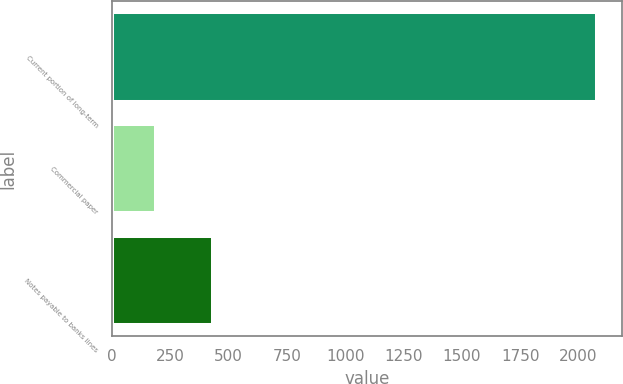Convert chart to OTSL. <chart><loc_0><loc_0><loc_500><loc_500><bar_chart><fcel>Current portion of long-term<fcel>Commercial paper<fcel>Notes payable to banks lines<nl><fcel>2081<fcel>190<fcel>434<nl></chart> 